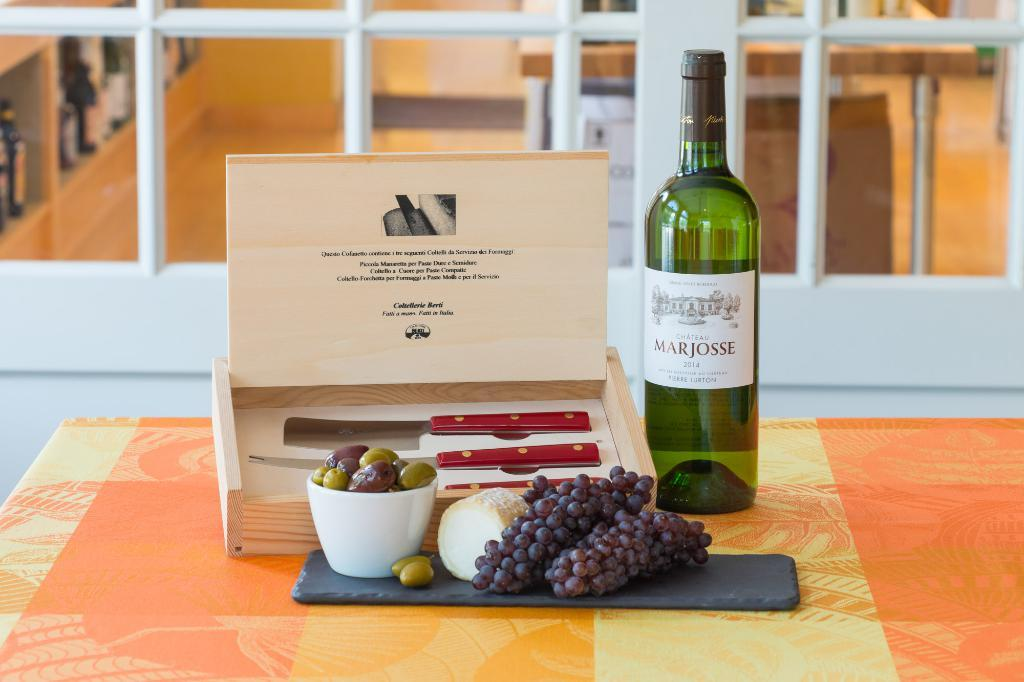<image>
Summarize the visual content of the image. Table full of fruits and a bottle with the name MARJOSSE. 